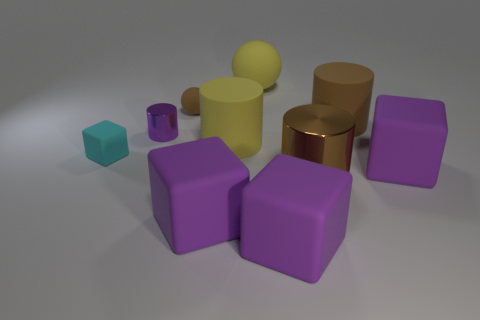There is a large ball that is made of the same material as the small brown sphere; what is its color? yellow 